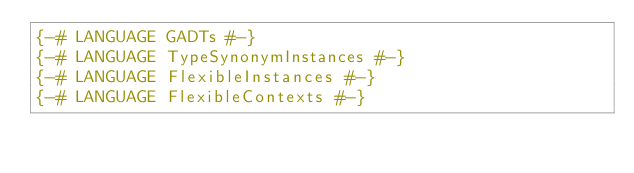Convert code to text. <code><loc_0><loc_0><loc_500><loc_500><_Haskell_>{-# LANGUAGE GADTs #-}
{-# LANGUAGE TypeSynonymInstances #-}
{-# LANGUAGE FlexibleInstances #-}
{-# LANGUAGE FlexibleContexts #-}</code> 